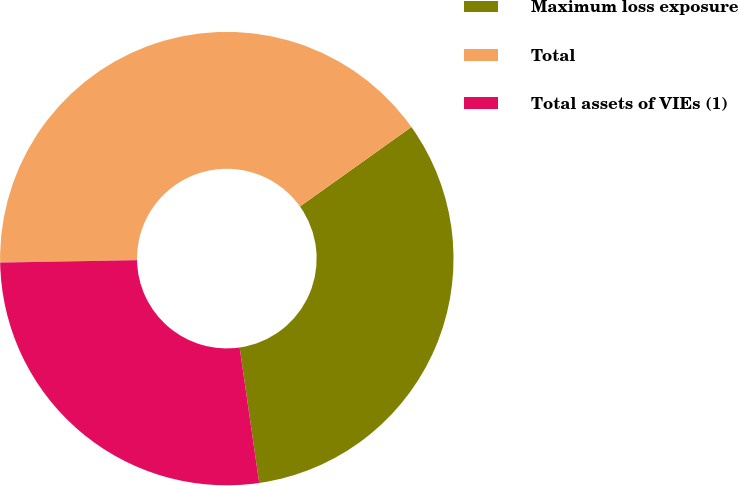Convert chart to OTSL. <chart><loc_0><loc_0><loc_500><loc_500><pie_chart><fcel>Maximum loss exposure<fcel>Total<fcel>Total assets of VIEs (1)<nl><fcel>32.57%<fcel>40.42%<fcel>27.0%<nl></chart> 